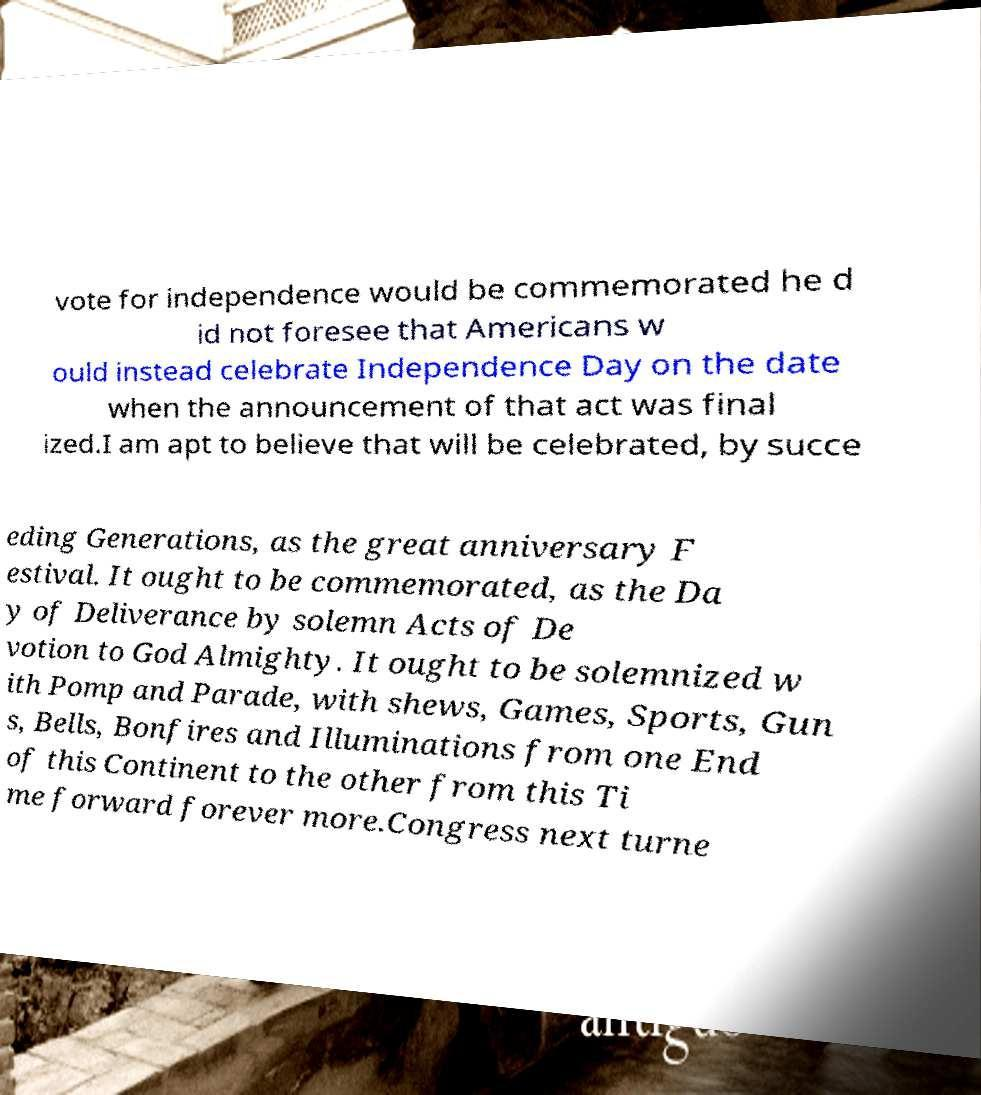Can you read and provide the text displayed in the image?This photo seems to have some interesting text. Can you extract and type it out for me? vote for independence would be commemorated he d id not foresee that Americans w ould instead celebrate Independence Day on the date when the announcement of that act was final ized.I am apt to believe that will be celebrated, by succe eding Generations, as the great anniversary F estival. It ought to be commemorated, as the Da y of Deliverance by solemn Acts of De votion to God Almighty. It ought to be solemnized w ith Pomp and Parade, with shews, Games, Sports, Gun s, Bells, Bonfires and Illuminations from one End of this Continent to the other from this Ti me forward forever more.Congress next turne 